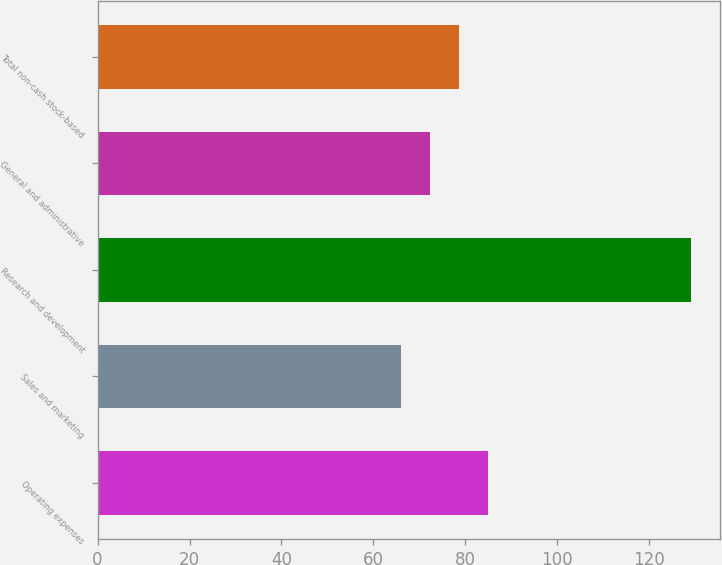Convert chart to OTSL. <chart><loc_0><loc_0><loc_500><loc_500><bar_chart><fcel>Operating expenses<fcel>Sales and marketing<fcel>Research and development<fcel>General and administrative<fcel>Total non-cash stock-based<nl><fcel>84.9<fcel>66<fcel>129<fcel>72.3<fcel>78.6<nl></chart> 